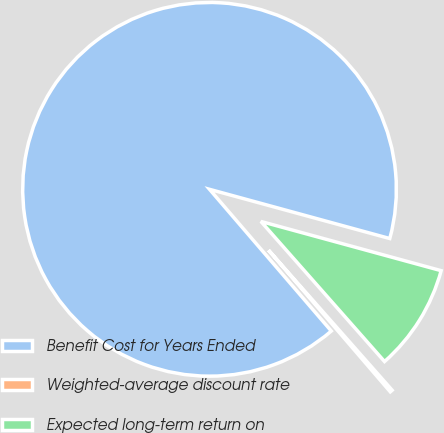Convert chart. <chart><loc_0><loc_0><loc_500><loc_500><pie_chart><fcel>Benefit Cost for Years Ended<fcel>Weighted-average discount rate<fcel>Expected long-term return on<nl><fcel>90.54%<fcel>0.21%<fcel>9.25%<nl></chart> 